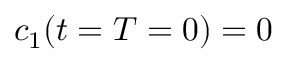<formula> <loc_0><loc_0><loc_500><loc_500>c _ { 1 } ( t = T = 0 ) = 0</formula> 